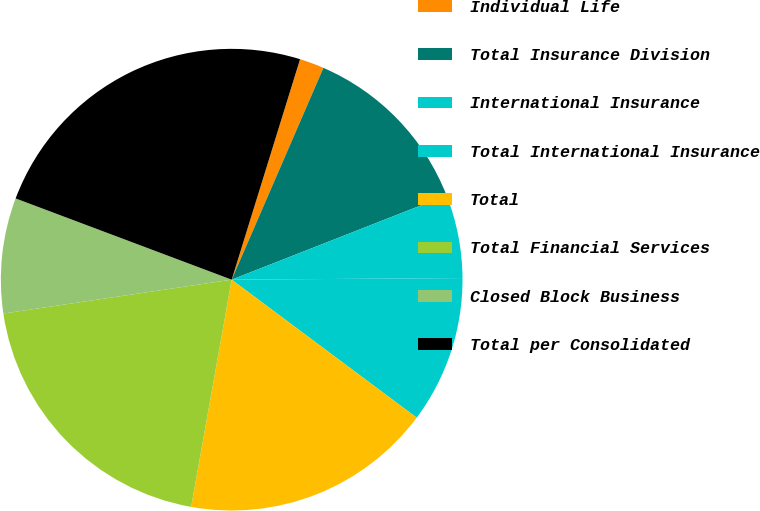<chart> <loc_0><loc_0><loc_500><loc_500><pie_chart><fcel>Individual Life<fcel>Total Insurance Division<fcel>International Insurance<fcel>Total International Insurance<fcel>Total<fcel>Total Financial Services<fcel>Closed Block Business<fcel>Total per Consolidated<nl><fcel>1.72%<fcel>12.54%<fcel>5.84%<fcel>10.31%<fcel>17.61%<fcel>19.84%<fcel>8.07%<fcel>24.06%<nl></chart> 